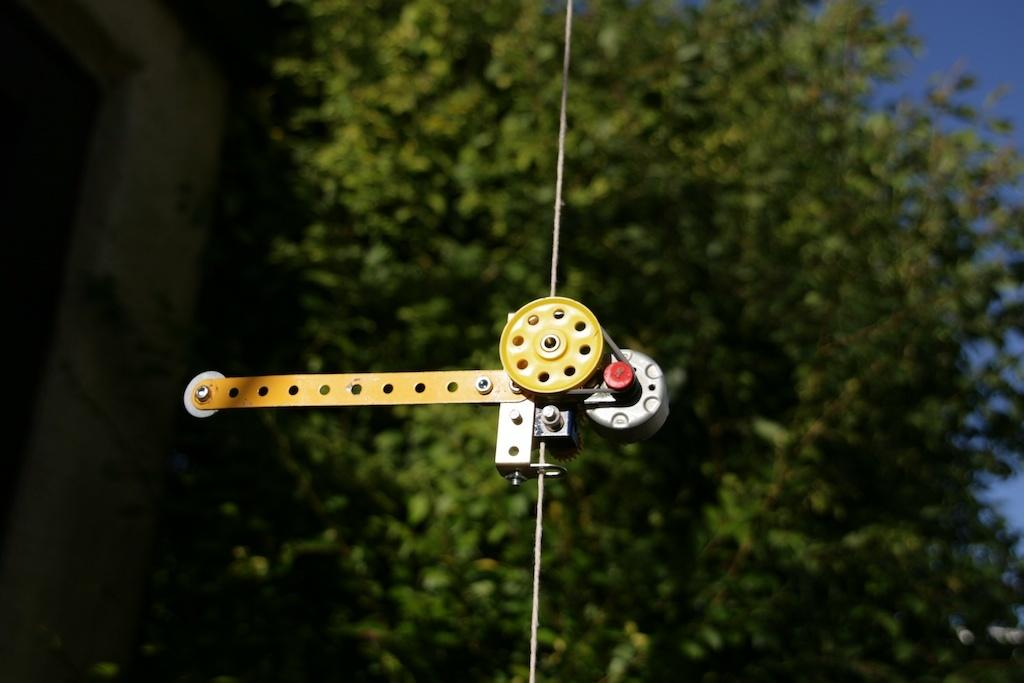What type of climbing equipment is visible in the picture? There is a revo belay device in the picture. What type of structure can be seen in the background? There is a building in the picture. What type of vegetation is present in the image? There are trees in the picture. What type of trail can be seen in the picture? There is no trail visible in the picture; it only shows a revo belay device, a building, and trees. 